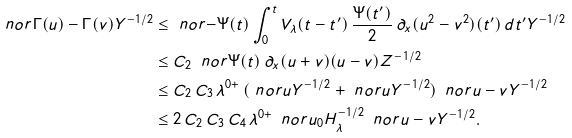<formula> <loc_0><loc_0><loc_500><loc_500>\ n o r { \Gamma ( u ) - \Gamma ( v ) } { Y ^ { - 1 / 2 } } & \leq \ n o r { - \Psi ( t ) \int _ { 0 } ^ { t } V _ { \lambda } ( t - t ^ { \prime } ) \, \frac { \Psi ( t ^ { \prime } ) } { 2 } \, \partial _ { x } ( u ^ { 2 } - v ^ { 2 } ) ( t ^ { \prime } ) \, d t ^ { \prime } } { Y ^ { - 1 / 2 } } \\ & \leq C _ { 2 } \, \ n o r { \Psi ( t ) \, \partial _ { x } ( u + v ) ( u - v ) } { Z ^ { - 1 / 2 } } \\ & \leq C _ { 2 } \, C _ { 3 } \, \lambda ^ { 0 + } \, ( \ n o r { u } { Y ^ { - 1 / 2 } } + \ n o r { u } { Y ^ { - 1 / 2 } } ) \, \ n o r { u - v } { Y ^ { - 1 / 2 } } \\ & \leq 2 \, C _ { 2 } \, C _ { 3 } \, C _ { 4 } \, \lambda ^ { 0 + } \, \ n o r { u _ { 0 } } { H ^ { - 1 / 2 } _ { \lambda } } \, \ n o r { u - v } { Y ^ { - 1 / 2 } } .</formula> 